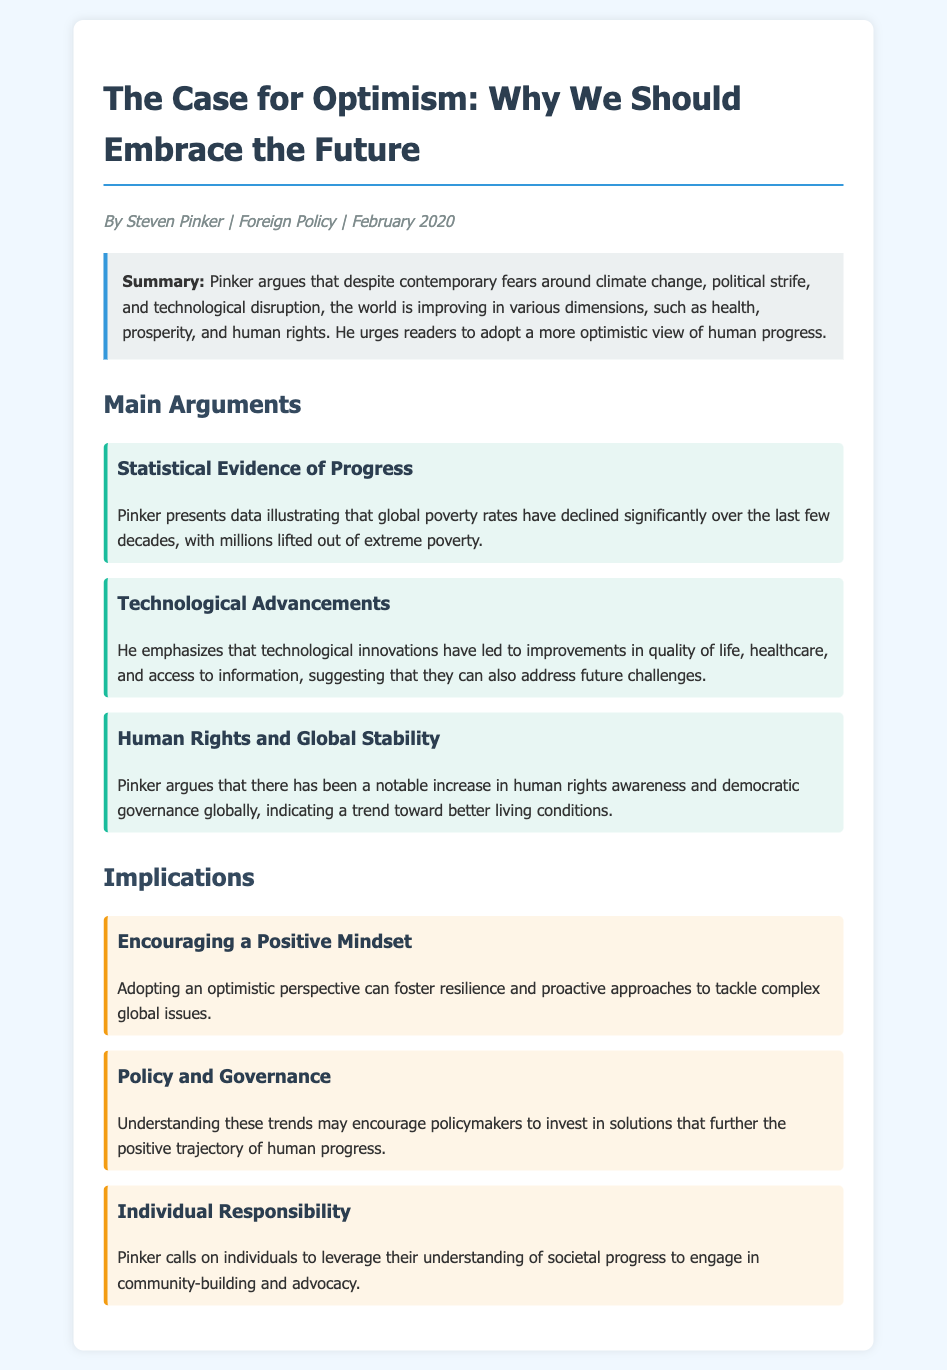What is the title of the article? The title is explicitly stated at the beginning of the document.
Answer: The Case for Optimism: Why We Should Embrace the Future Who is the author of the article? The author's name is mentioned in the meta section right below the title.
Answer: Steven Pinker When was the article published? The publication date is also provided in the meta section of the document.
Answer: February 2020 What is the main argument regarding poverty? The document highlights the main arguments about poverty in the section dedicated to it.
Answer: Global poverty rates have declined significantly What does Pinker emphasize about technological advancements? This is explained under the argument section that focuses on technological innovations.
Answer: Improvements in quality of life, healthcare, and access to information What is one implication of adopting an optimistic perspective? This is found in the implications section where the effects of an optimistic view are discussed.
Answer: Foster resilience and proactive approaches How does Pinker suggest individuals can engage with societal progress? The document contains suggestions on individual responsibilities in the implication section.
Answer: Community-building and advocacy 